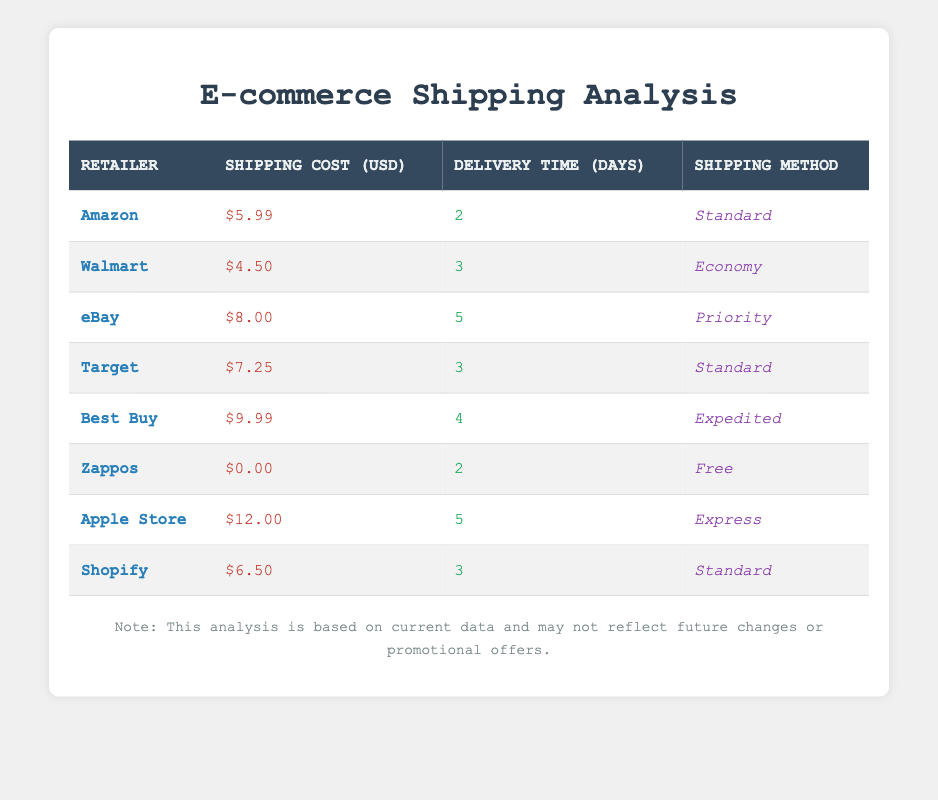What is the shipping cost for Walmart? The table shows a specific row for Walmart, where the shipping cost is listed as $4.50.
Answer: $4.50 Which retailer has the longest delivery time? By examining the "Delivery Time (Days)" column, eBay and Apple Store both show a delivery time of 5 days, which is the maximum among all retailers.
Answer: eBay and Apple Store What is the average shipping cost across all retailers? To find the average, we first sum the shipping costs: 5.99 + 4.50 + 8.00 + 7.25 + 9.99 + 0.00 + 12.00 + 6.50 = 54.23. Then, we divide by the number of retailers (8): 54.23 / 8 = 6.78.
Answer: 6.78 Is Zappos the only retailer with free shipping? Looking at the "Shipping Cost (USD)" column, Zappos shows $0.00 while all other retailers list positive shipping costs. Thus, Zappos is indeed the only retailer with free shipping.
Answer: Yes What is the difference in delivery time between the fastest and the slowest shipping methods? The fastest delivery time is 2 days (for both Amazon and Zappos), while the slowest delivery time is 5 days (for eBay and Apple Store). The difference is 5 - 2 = 3 days.
Answer: 3 days Which shipping method has a cost greater than $10? Scanning the "Shipping Cost (USD)" column, we see that only the Apple Store lists a shipping cost greater than $10, which is $12.00.
Answer: Yes Are there any retailers with a shipping cost of $6.50 or lower? By checking the "Shipping Cost (USD)" column, Walmart ($4.50), Target ($7.25), and Shopify ($6.50) fall into this category. Since Walmart and Shopify meet this criterion, the answer is yes.
Answer: Yes What is the total shipping cost for the retailers that offer delivery in 2 days? The retailers offering 2-day delivery are Amazon ($5.99) and Zappos ($0.00). Adding these costs gives us 5.99 + 0.00 = $5.99.
Answer: $5.99 Which retailer has the lowest shipping cost and what is their delivery time? Looking at the table, Zappos has the lowest shipping cost of $0.00, and its corresponding delivery time is 2 days.
Answer: Zappos, 2 days 